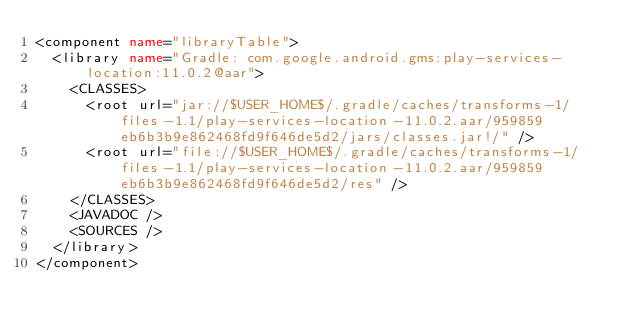<code> <loc_0><loc_0><loc_500><loc_500><_XML_><component name="libraryTable">
  <library name="Gradle: com.google.android.gms:play-services-location:11.0.2@aar">
    <CLASSES>
      <root url="jar://$USER_HOME$/.gradle/caches/transforms-1/files-1.1/play-services-location-11.0.2.aar/959859eb6b3b9e862468fd9f646de5d2/jars/classes.jar!/" />
      <root url="file://$USER_HOME$/.gradle/caches/transforms-1/files-1.1/play-services-location-11.0.2.aar/959859eb6b3b9e862468fd9f646de5d2/res" />
    </CLASSES>
    <JAVADOC />
    <SOURCES />
  </library>
</component></code> 